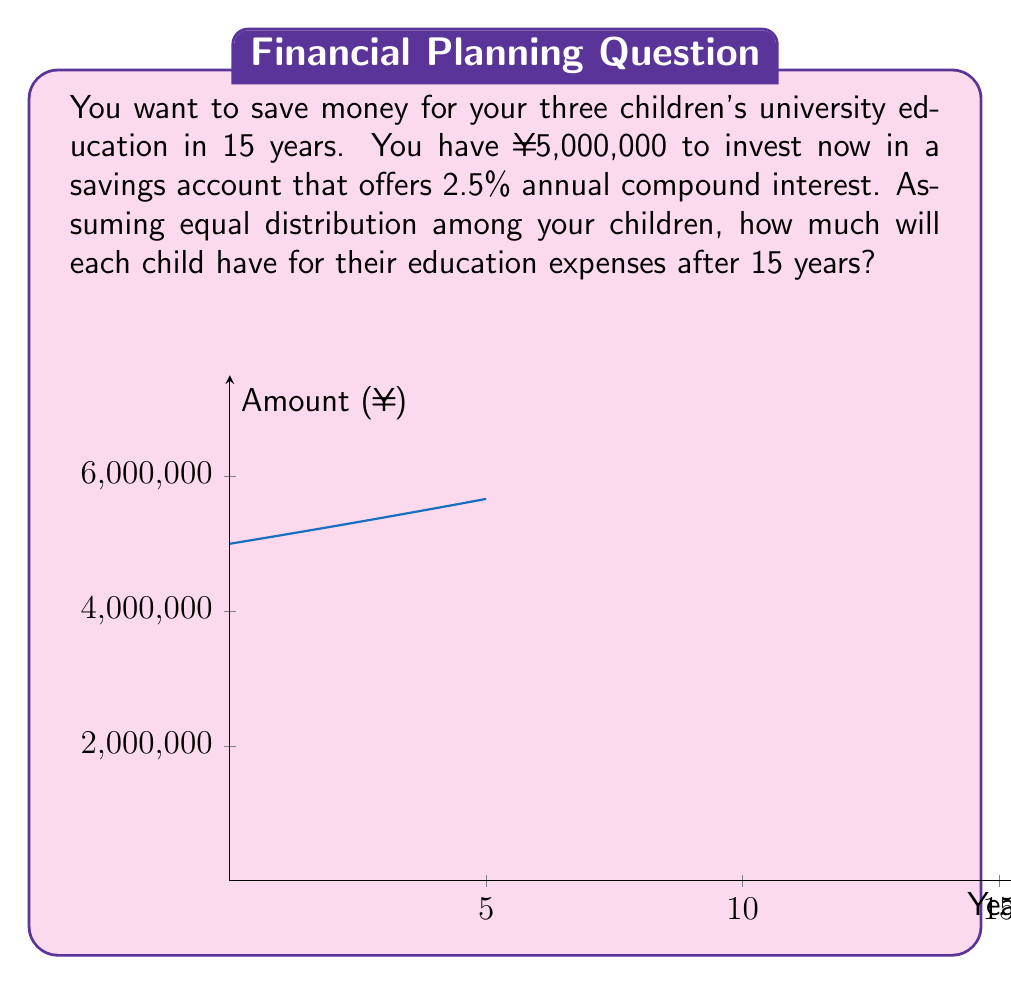Teach me how to tackle this problem. Let's approach this step-by-step:

1) The formula for compound interest is:
   $$A = P(1 + r)^t$$
   Where:
   $A$ = final amount
   $P$ = principal (initial investment)
   $r$ = annual interest rate (in decimal form)
   $t$ = time in years

2) We have:
   $P = ¥5,000,000$
   $r = 2.5\% = 0.025$
   $t = 15$ years

3) Let's plug these values into our formula:
   $$A = 5,000,000(1 + 0.025)^{15}$$

4) Calculate:
   $$A = 5,000,000(1.025)^{15}$$
   $$A = 5,000,000(1.4463)$$
   $$A = 7,231,500$$

5) This is the total amount after 15 years. To find the amount for each child, we divide by 3:
   $$\frac{7,231,500}{3} = 2,410,500$$

Therefore, each child will have ¥2,410,500 for their education expenses.
Answer: ¥2,410,500 per child 